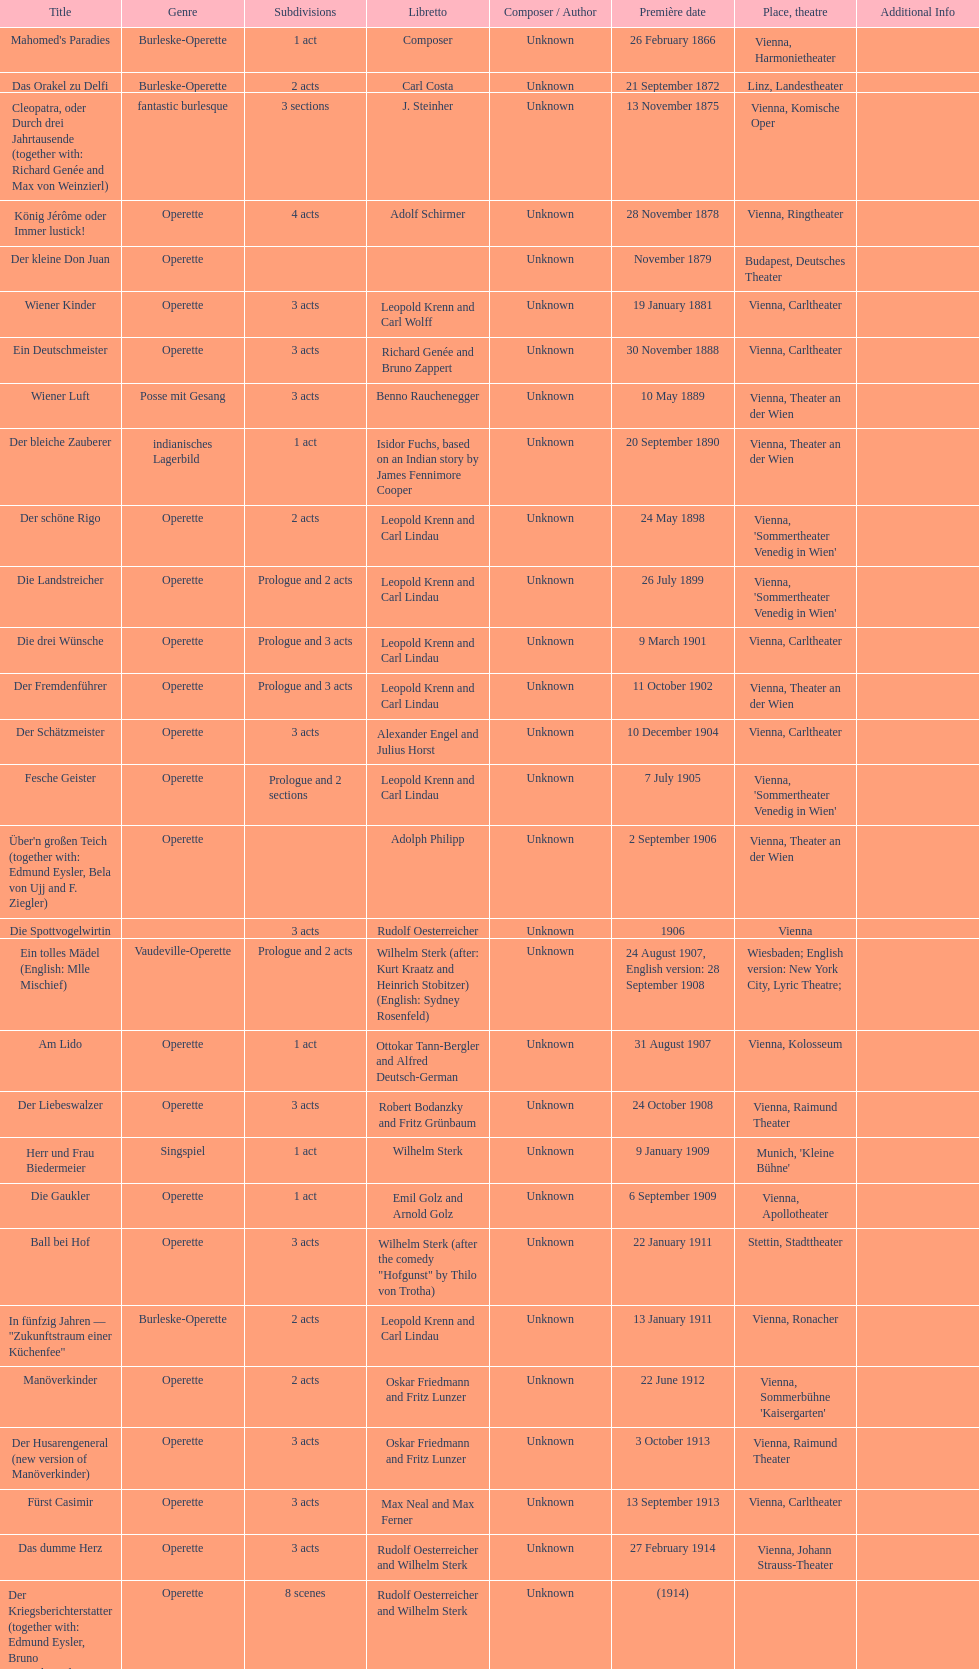What was the year of the last title? 1958. 